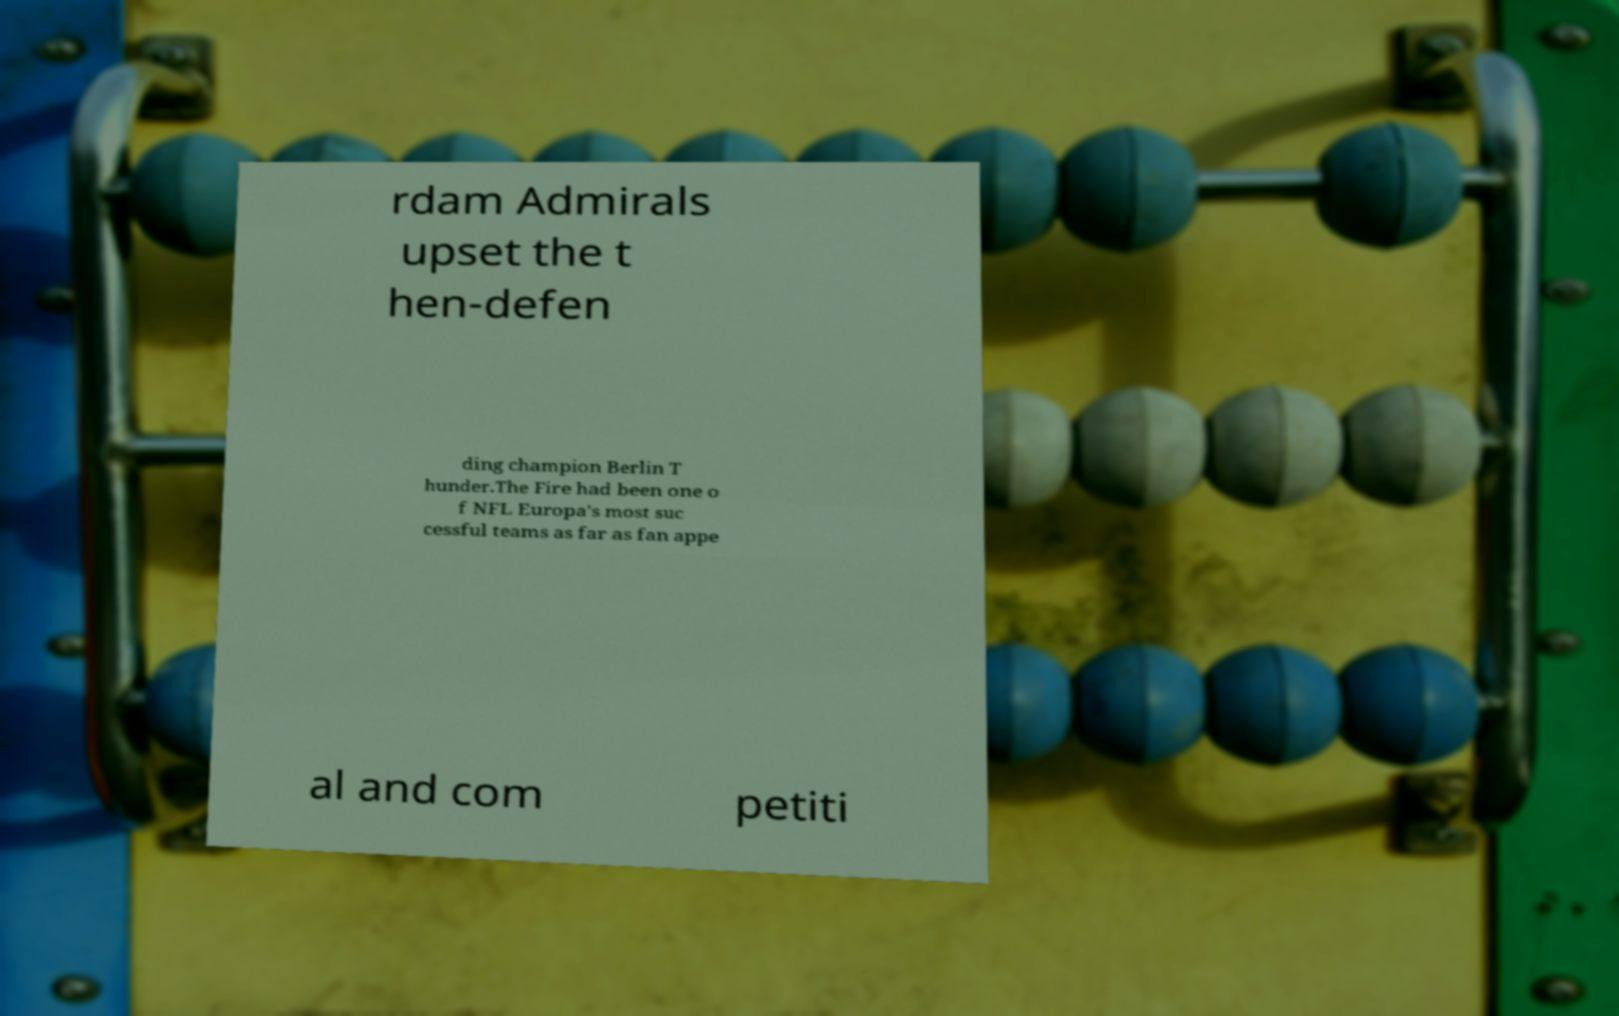For documentation purposes, I need the text within this image transcribed. Could you provide that? rdam Admirals upset the t hen-defen ding champion Berlin T hunder.The Fire had been one o f NFL Europa's most suc cessful teams as far as fan appe al and com petiti 